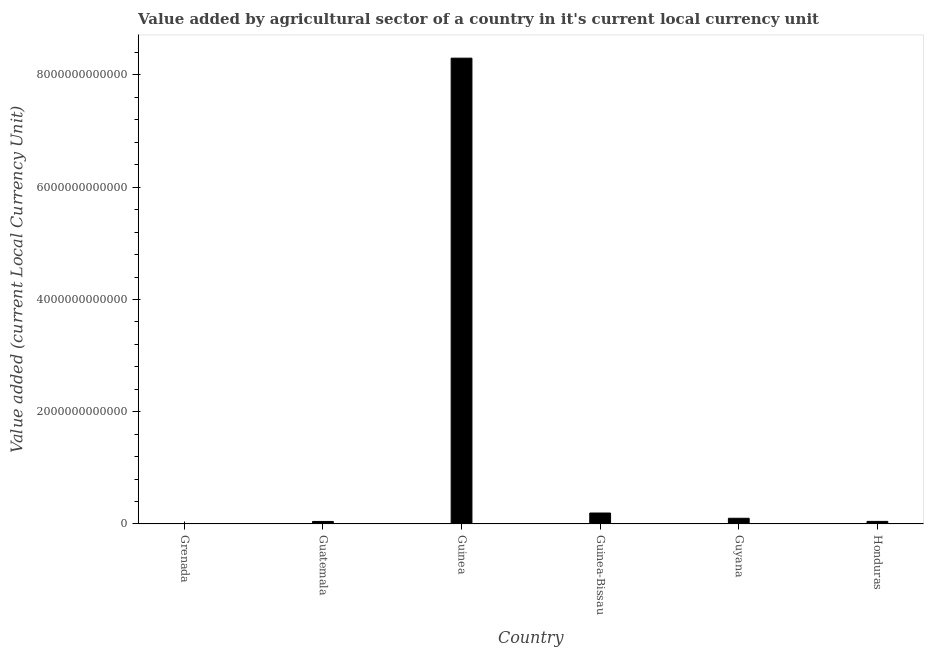Does the graph contain any zero values?
Your answer should be very brief. No. Does the graph contain grids?
Your answer should be compact. No. What is the title of the graph?
Your response must be concise. Value added by agricultural sector of a country in it's current local currency unit. What is the label or title of the Y-axis?
Your answer should be compact. Value added (current Local Currency Unit). What is the value added by agriculture sector in Guatemala?
Offer a terse response. 4.50e+1. Across all countries, what is the maximum value added by agriculture sector?
Provide a short and direct response. 8.30e+12. Across all countries, what is the minimum value added by agriculture sector?
Provide a succinct answer. 1.10e+08. In which country was the value added by agriculture sector maximum?
Offer a very short reply. Guinea. In which country was the value added by agriculture sector minimum?
Keep it short and to the point. Grenada. What is the sum of the value added by agriculture sector?
Your answer should be very brief. 8.69e+12. What is the difference between the value added by agriculture sector in Grenada and Guinea-Bissau?
Offer a very short reply. -1.95e+11. What is the average value added by agriculture sector per country?
Keep it short and to the point. 1.45e+12. What is the median value added by agriculture sector?
Give a very brief answer. 7.37e+1. What is the ratio of the value added by agriculture sector in Guinea-Bissau to that in Guyana?
Offer a very short reply. 1.92. Is the difference between the value added by agriculture sector in Guatemala and Guinea greater than the difference between any two countries?
Provide a succinct answer. No. What is the difference between the highest and the second highest value added by agriculture sector?
Make the answer very short. 8.10e+12. Is the sum of the value added by agriculture sector in Guinea and Guyana greater than the maximum value added by agriculture sector across all countries?
Give a very brief answer. Yes. What is the difference between the highest and the lowest value added by agriculture sector?
Keep it short and to the point. 8.30e+12. In how many countries, is the value added by agriculture sector greater than the average value added by agriculture sector taken over all countries?
Give a very brief answer. 1. What is the difference between two consecutive major ticks on the Y-axis?
Make the answer very short. 2.00e+12. Are the values on the major ticks of Y-axis written in scientific E-notation?
Provide a succinct answer. No. What is the Value added (current Local Currency Unit) in Grenada?
Provide a short and direct response. 1.10e+08. What is the Value added (current Local Currency Unit) in Guatemala?
Keep it short and to the point. 4.50e+1. What is the Value added (current Local Currency Unit) of Guinea?
Give a very brief answer. 8.30e+12. What is the Value added (current Local Currency Unit) in Guinea-Bissau?
Keep it short and to the point. 1.95e+11. What is the Value added (current Local Currency Unit) in Guyana?
Provide a short and direct response. 1.02e+11. What is the Value added (current Local Currency Unit) of Honduras?
Your answer should be compact. 4.59e+1. What is the difference between the Value added (current Local Currency Unit) in Grenada and Guatemala?
Make the answer very short. -4.49e+1. What is the difference between the Value added (current Local Currency Unit) in Grenada and Guinea?
Your response must be concise. -8.30e+12. What is the difference between the Value added (current Local Currency Unit) in Grenada and Guinea-Bissau?
Your answer should be very brief. -1.95e+11. What is the difference between the Value added (current Local Currency Unit) in Grenada and Guyana?
Provide a succinct answer. -1.01e+11. What is the difference between the Value added (current Local Currency Unit) in Grenada and Honduras?
Offer a terse response. -4.58e+1. What is the difference between the Value added (current Local Currency Unit) in Guatemala and Guinea?
Make the answer very short. -8.25e+12. What is the difference between the Value added (current Local Currency Unit) in Guatemala and Guinea-Bissau?
Provide a succinct answer. -1.50e+11. What is the difference between the Value added (current Local Currency Unit) in Guatemala and Guyana?
Your answer should be very brief. -5.66e+1. What is the difference between the Value added (current Local Currency Unit) in Guatemala and Honduras?
Your response must be concise. -9.16e+08. What is the difference between the Value added (current Local Currency Unit) in Guinea and Guinea-Bissau?
Ensure brevity in your answer.  8.10e+12. What is the difference between the Value added (current Local Currency Unit) in Guinea and Guyana?
Keep it short and to the point. 8.20e+12. What is the difference between the Value added (current Local Currency Unit) in Guinea and Honduras?
Your answer should be compact. 8.25e+12. What is the difference between the Value added (current Local Currency Unit) in Guinea-Bissau and Guyana?
Keep it short and to the point. 9.38e+1. What is the difference between the Value added (current Local Currency Unit) in Guinea-Bissau and Honduras?
Your response must be concise. 1.49e+11. What is the difference between the Value added (current Local Currency Unit) in Guyana and Honduras?
Ensure brevity in your answer.  5.56e+1. What is the ratio of the Value added (current Local Currency Unit) in Grenada to that in Guatemala?
Make the answer very short. 0. What is the ratio of the Value added (current Local Currency Unit) in Grenada to that in Honduras?
Make the answer very short. 0. What is the ratio of the Value added (current Local Currency Unit) in Guatemala to that in Guinea?
Ensure brevity in your answer.  0.01. What is the ratio of the Value added (current Local Currency Unit) in Guatemala to that in Guinea-Bissau?
Provide a succinct answer. 0.23. What is the ratio of the Value added (current Local Currency Unit) in Guatemala to that in Guyana?
Your response must be concise. 0.44. What is the ratio of the Value added (current Local Currency Unit) in Guinea to that in Guinea-Bissau?
Offer a very short reply. 42.49. What is the ratio of the Value added (current Local Currency Unit) in Guinea to that in Guyana?
Provide a succinct answer. 81.73. What is the ratio of the Value added (current Local Currency Unit) in Guinea to that in Honduras?
Provide a succinct answer. 180.81. What is the ratio of the Value added (current Local Currency Unit) in Guinea-Bissau to that in Guyana?
Make the answer very short. 1.92. What is the ratio of the Value added (current Local Currency Unit) in Guinea-Bissau to that in Honduras?
Your answer should be compact. 4.25. What is the ratio of the Value added (current Local Currency Unit) in Guyana to that in Honduras?
Provide a succinct answer. 2.21. 